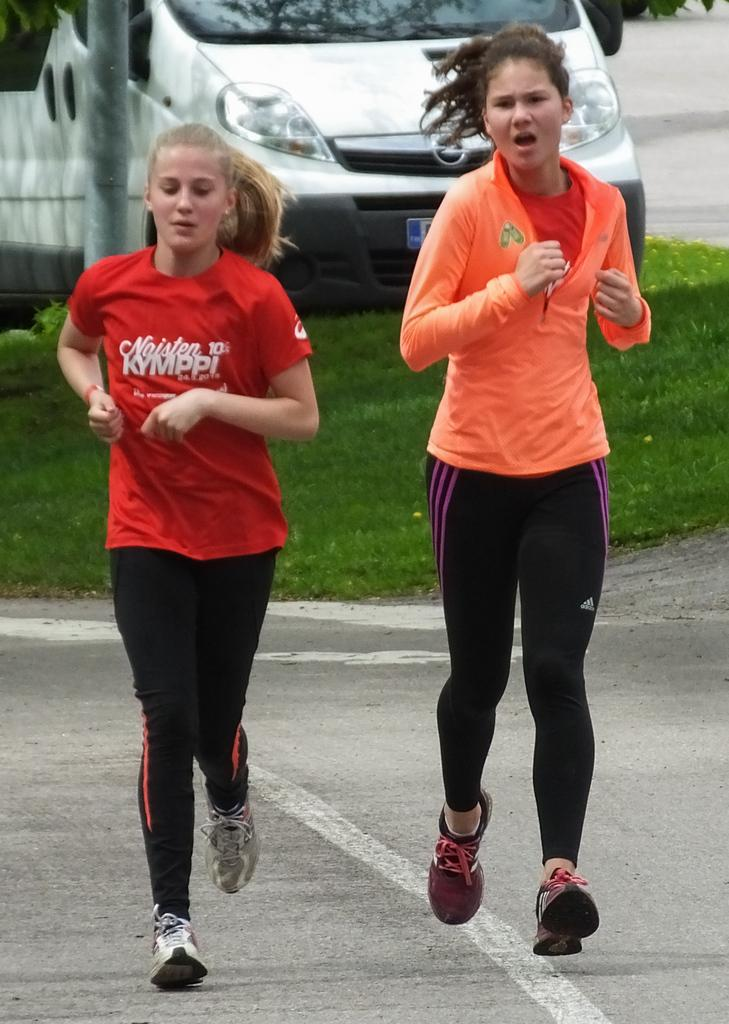How many girls are in the image? There are two girls in the image. What are the girls doing in the image? The girls are running on the road in the image. What else can be seen in the image besides the girls? There is a vehicle parked on the grass, and a pole beside the vehicle. How is the vehicle positioned in the image? The vehicle is parked on the surface of the grass. What type of metal is the beast sneezing in the image? There is no beast or metal present in the image, and no sneezing is depicted. 